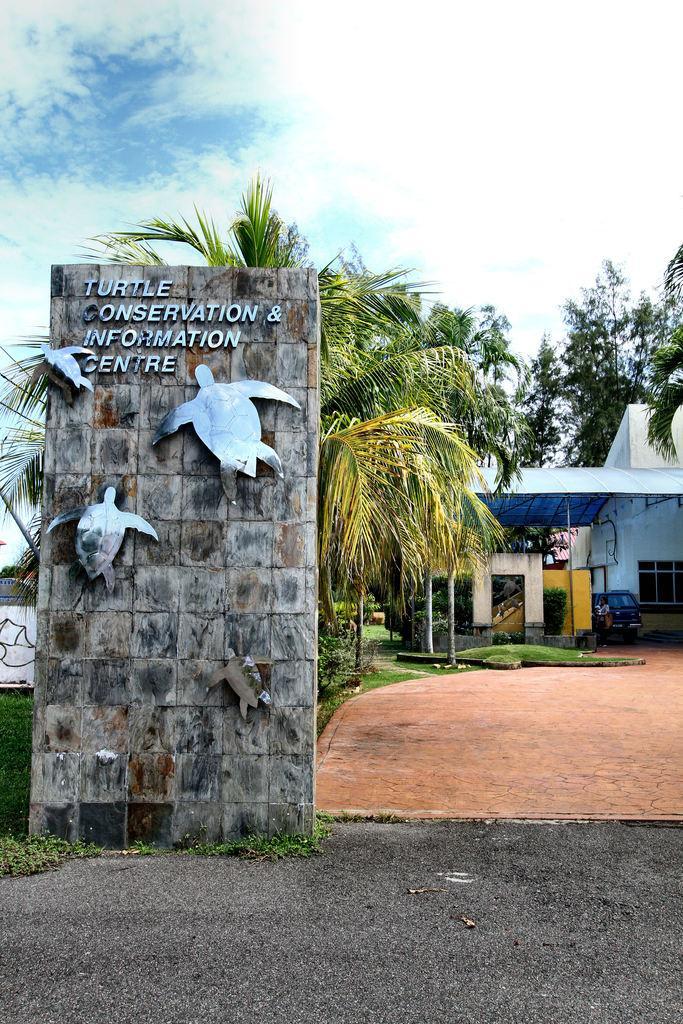Please provide a concise description of this image. As we can see in the image there are trees, buildings, plants, grass, sky and clouds. 